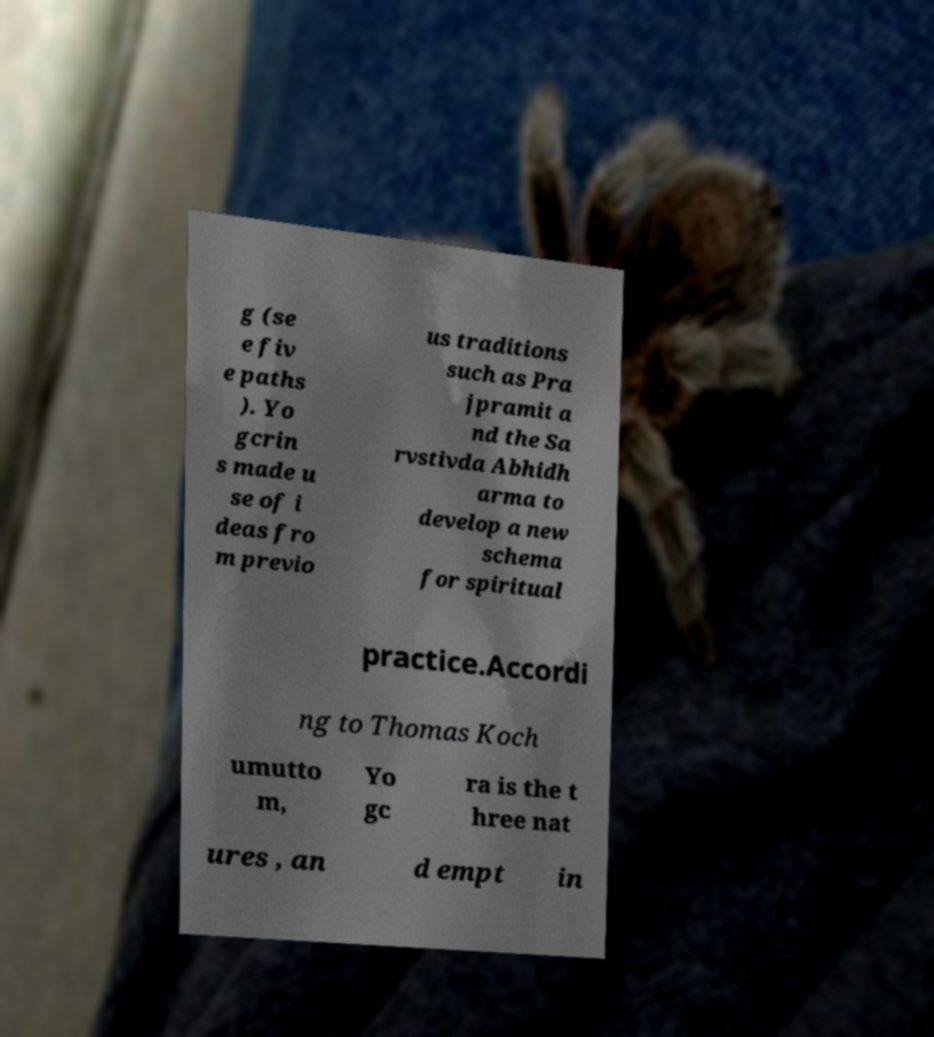Can you read and provide the text displayed in the image?This photo seems to have some interesting text. Can you extract and type it out for me? g (se e fiv e paths ). Yo gcrin s made u se of i deas fro m previo us traditions such as Pra jpramit a nd the Sa rvstivda Abhidh arma to develop a new schema for spiritual practice.Accordi ng to Thomas Koch umutto m, Yo gc ra is the t hree nat ures , an d empt in 